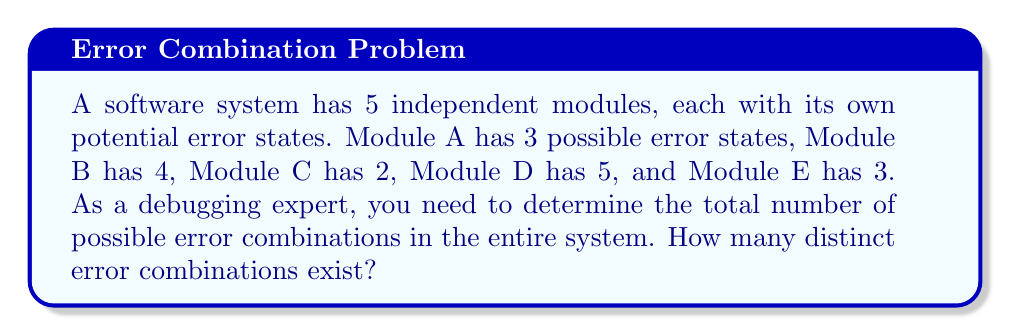Help me with this question. To solve this problem, we'll use the Multiplication Principle of Counting. Since the modules are independent and can be in any of their error states simultaneously, we multiply the number of possibilities for each module:

1. Module A: 3 error states
2. Module B: 4 error states
3. Module C: 2 error states
4. Module D: 5 error states
5. Module E: 3 error states

The total number of possible error combinations is:

$$ 3 \times 4 \times 2 \times 5 \times 3 = 360 $$

This calculation accounts for all possible combinations of error states across all modules. Each combination represents a unique error scenario that a debugging expert might encounter.

To break it down further:
1. For each error state of Module A (3 options), we have:
   - 4 options for Module B
   - For each of those, 2 options for Module C
   - For each of those, 5 options for Module D
   - And for each of those, 3 options for Module E

This multiplicative process ensures we count every possible combination exactly once.
Answer: 360 